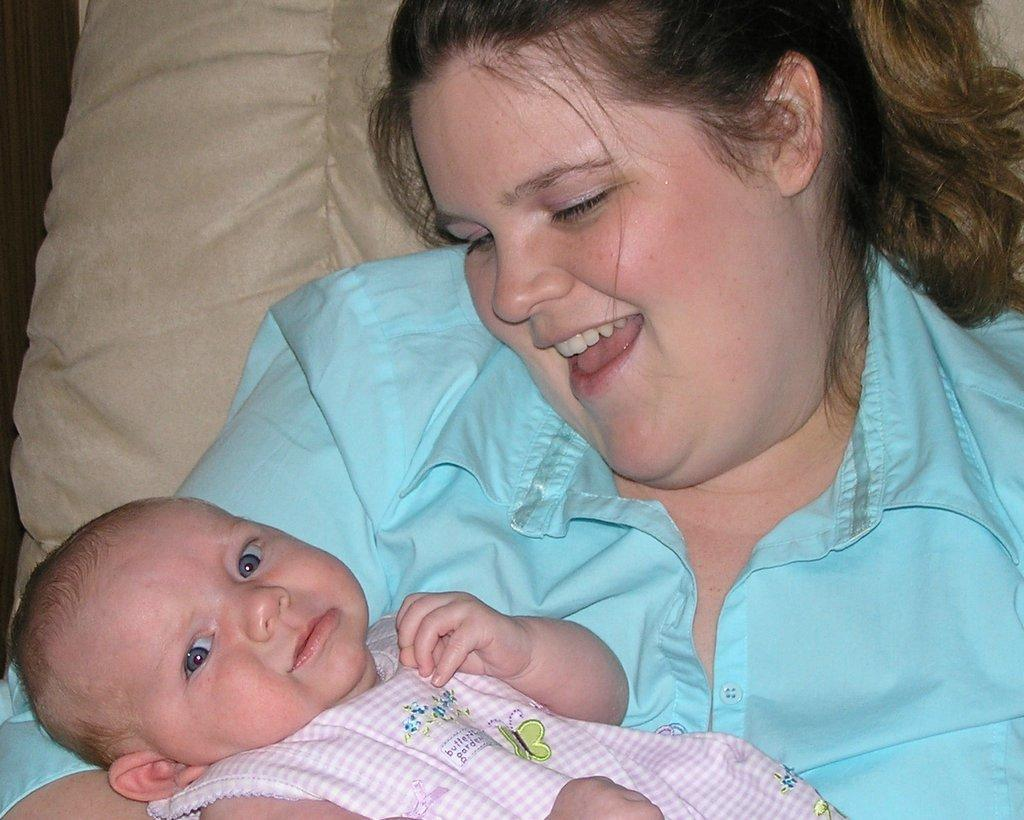What is the person in the image doing? The person is holding a baby in the image. What is the person wearing? The person is wearing a blue color shirt. What can be seen in the background of the image? There is a cream color cloth in the background of the image. What type of grass is growing on the person's hand in the image? There is no grass present in the image; the person is holding a baby. 